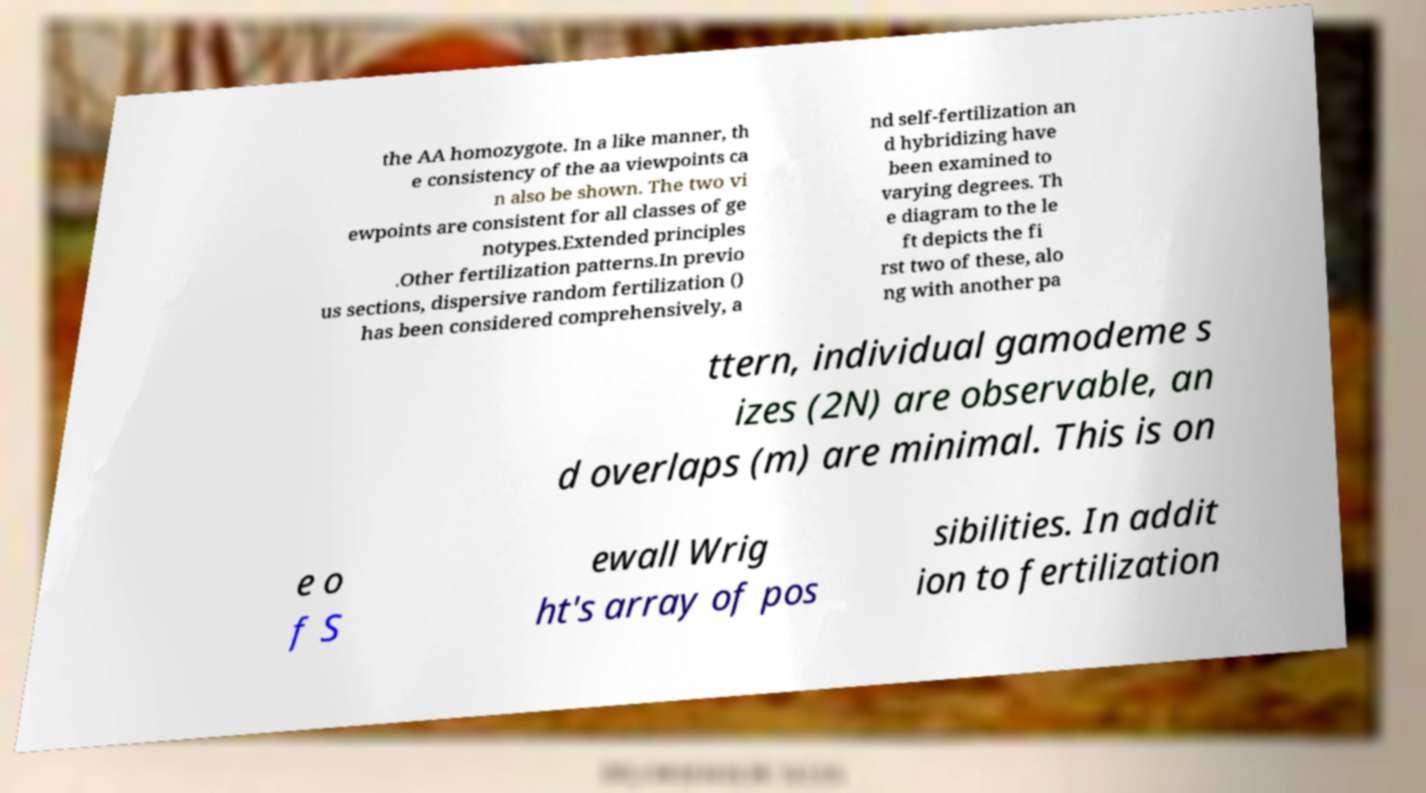Can you read and provide the text displayed in the image?This photo seems to have some interesting text. Can you extract and type it out for me? the AA homozygote. In a like manner, th e consistency of the aa viewpoints ca n also be shown. The two vi ewpoints are consistent for all classes of ge notypes.Extended principles .Other fertilization patterns.In previo us sections, dispersive random fertilization () has been considered comprehensively, a nd self-fertilization an d hybridizing have been examined to varying degrees. Th e diagram to the le ft depicts the fi rst two of these, alo ng with another pa ttern, individual gamodeme s izes (2N) are observable, an d overlaps (m) are minimal. This is on e o f S ewall Wrig ht's array of pos sibilities. In addit ion to fertilization 